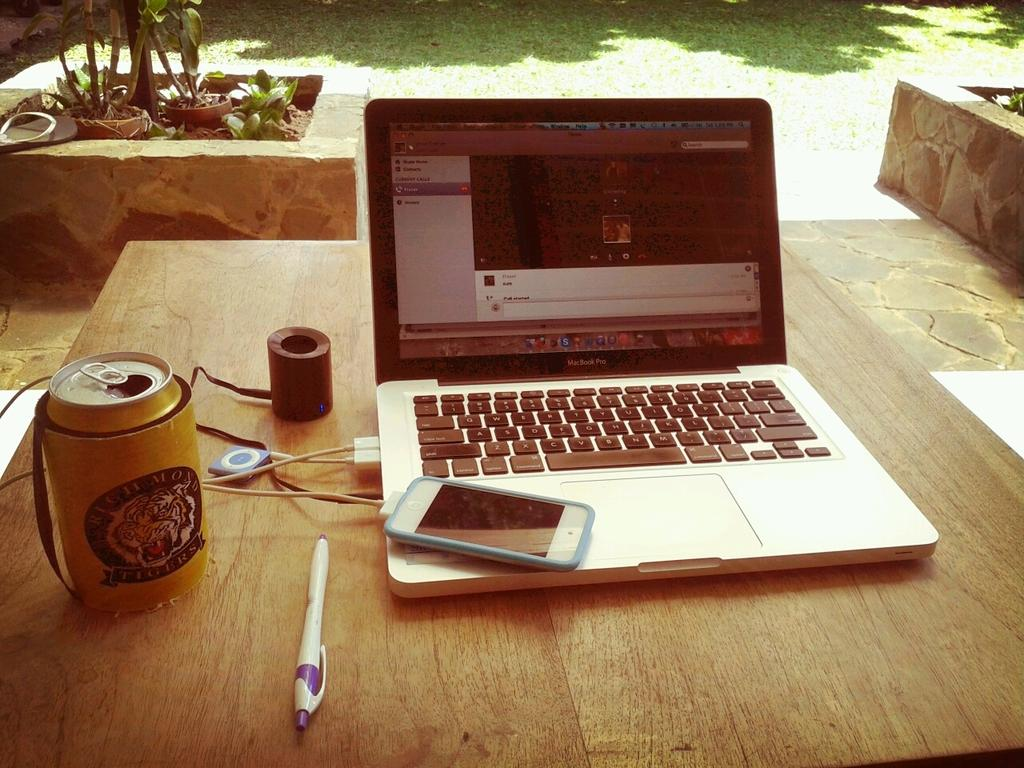What type of furniture is in the image? There is a table in the image. What electronic device is on the table? A MacBook is present on the table. What other electronic device is on the table? A mobile phone is on the table. What else can be seen on the table? There are other objects on the table. What can be seen in the background of the image? The background of the image is greenery. What is the condition of the stretch in the image? There is no stretch present in the image. 